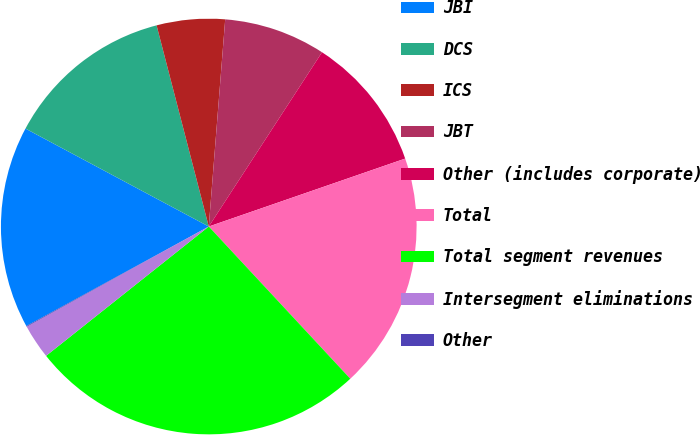Convert chart. <chart><loc_0><loc_0><loc_500><loc_500><pie_chart><fcel>JBI<fcel>DCS<fcel>ICS<fcel>JBT<fcel>Other (includes corporate)<fcel>Total<fcel>Total segment revenues<fcel>Intersegment eliminations<fcel>Other<nl><fcel>15.76%<fcel>13.15%<fcel>5.3%<fcel>7.91%<fcel>10.53%<fcel>18.38%<fcel>26.23%<fcel>2.68%<fcel>0.06%<nl></chart> 